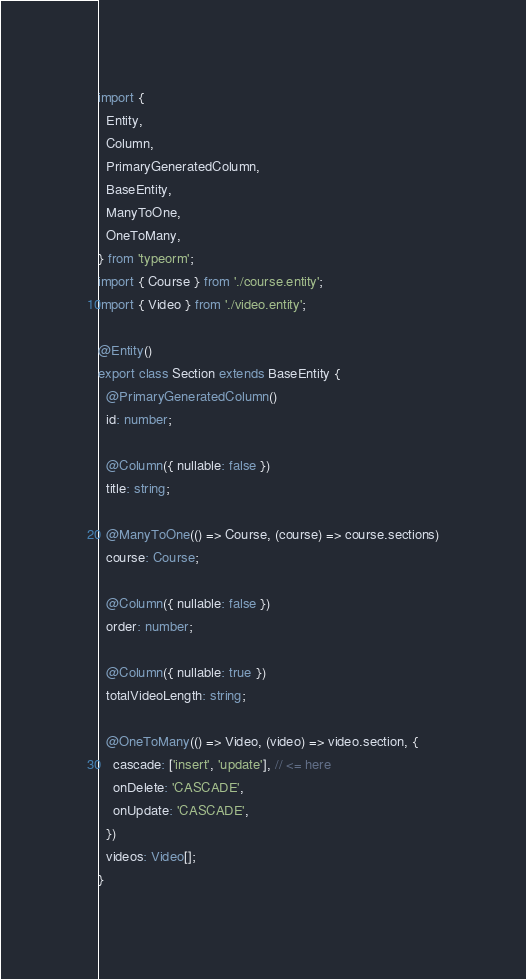<code> <loc_0><loc_0><loc_500><loc_500><_TypeScript_>import {
  Entity,
  Column,
  PrimaryGeneratedColumn,
  BaseEntity,
  ManyToOne,
  OneToMany,
} from 'typeorm';
import { Course } from './course.entity';
import { Video } from './video.entity';

@Entity()
export class Section extends BaseEntity {
  @PrimaryGeneratedColumn()
  id: number;

  @Column({ nullable: false })
  title: string;

  @ManyToOne(() => Course, (course) => course.sections)
  course: Course;

  @Column({ nullable: false })
  order: number;

  @Column({ nullable: true })
  totalVideoLength: string;

  @OneToMany(() => Video, (video) => video.section, {
    cascade: ['insert', 'update'], // <= here
    onDelete: 'CASCADE',
    onUpdate: 'CASCADE',
  })
  videos: Video[];
}
</code> 